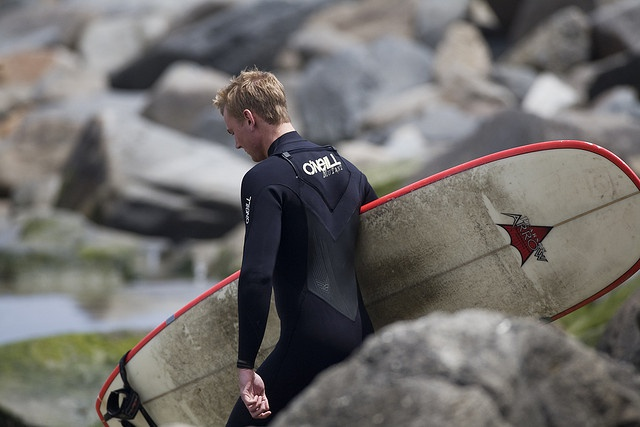Describe the objects in this image and their specific colors. I can see surfboard in gray, darkgray, and black tones and people in gray, black, and maroon tones in this image. 